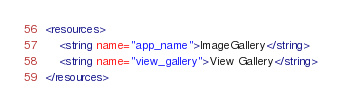Convert code to text. <code><loc_0><loc_0><loc_500><loc_500><_XML_><resources>
    <string name="app_name">ImageGallery</string>
    <string name="view_gallery">View Gallery</string>
</resources>
</code> 